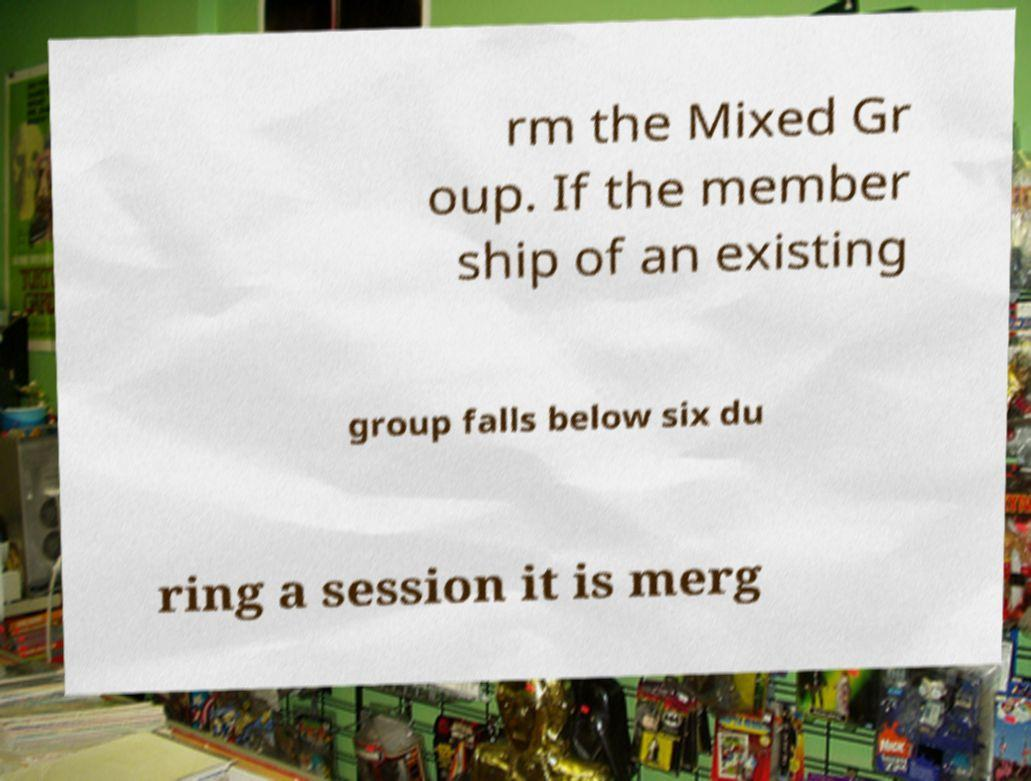Can you accurately transcribe the text from the provided image for me? rm the Mixed Gr oup. If the member ship of an existing group falls below six du ring a session it is merg 